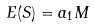Convert formula to latex. <formula><loc_0><loc_0><loc_500><loc_500>E ( S ) = a _ { 1 } M</formula> 